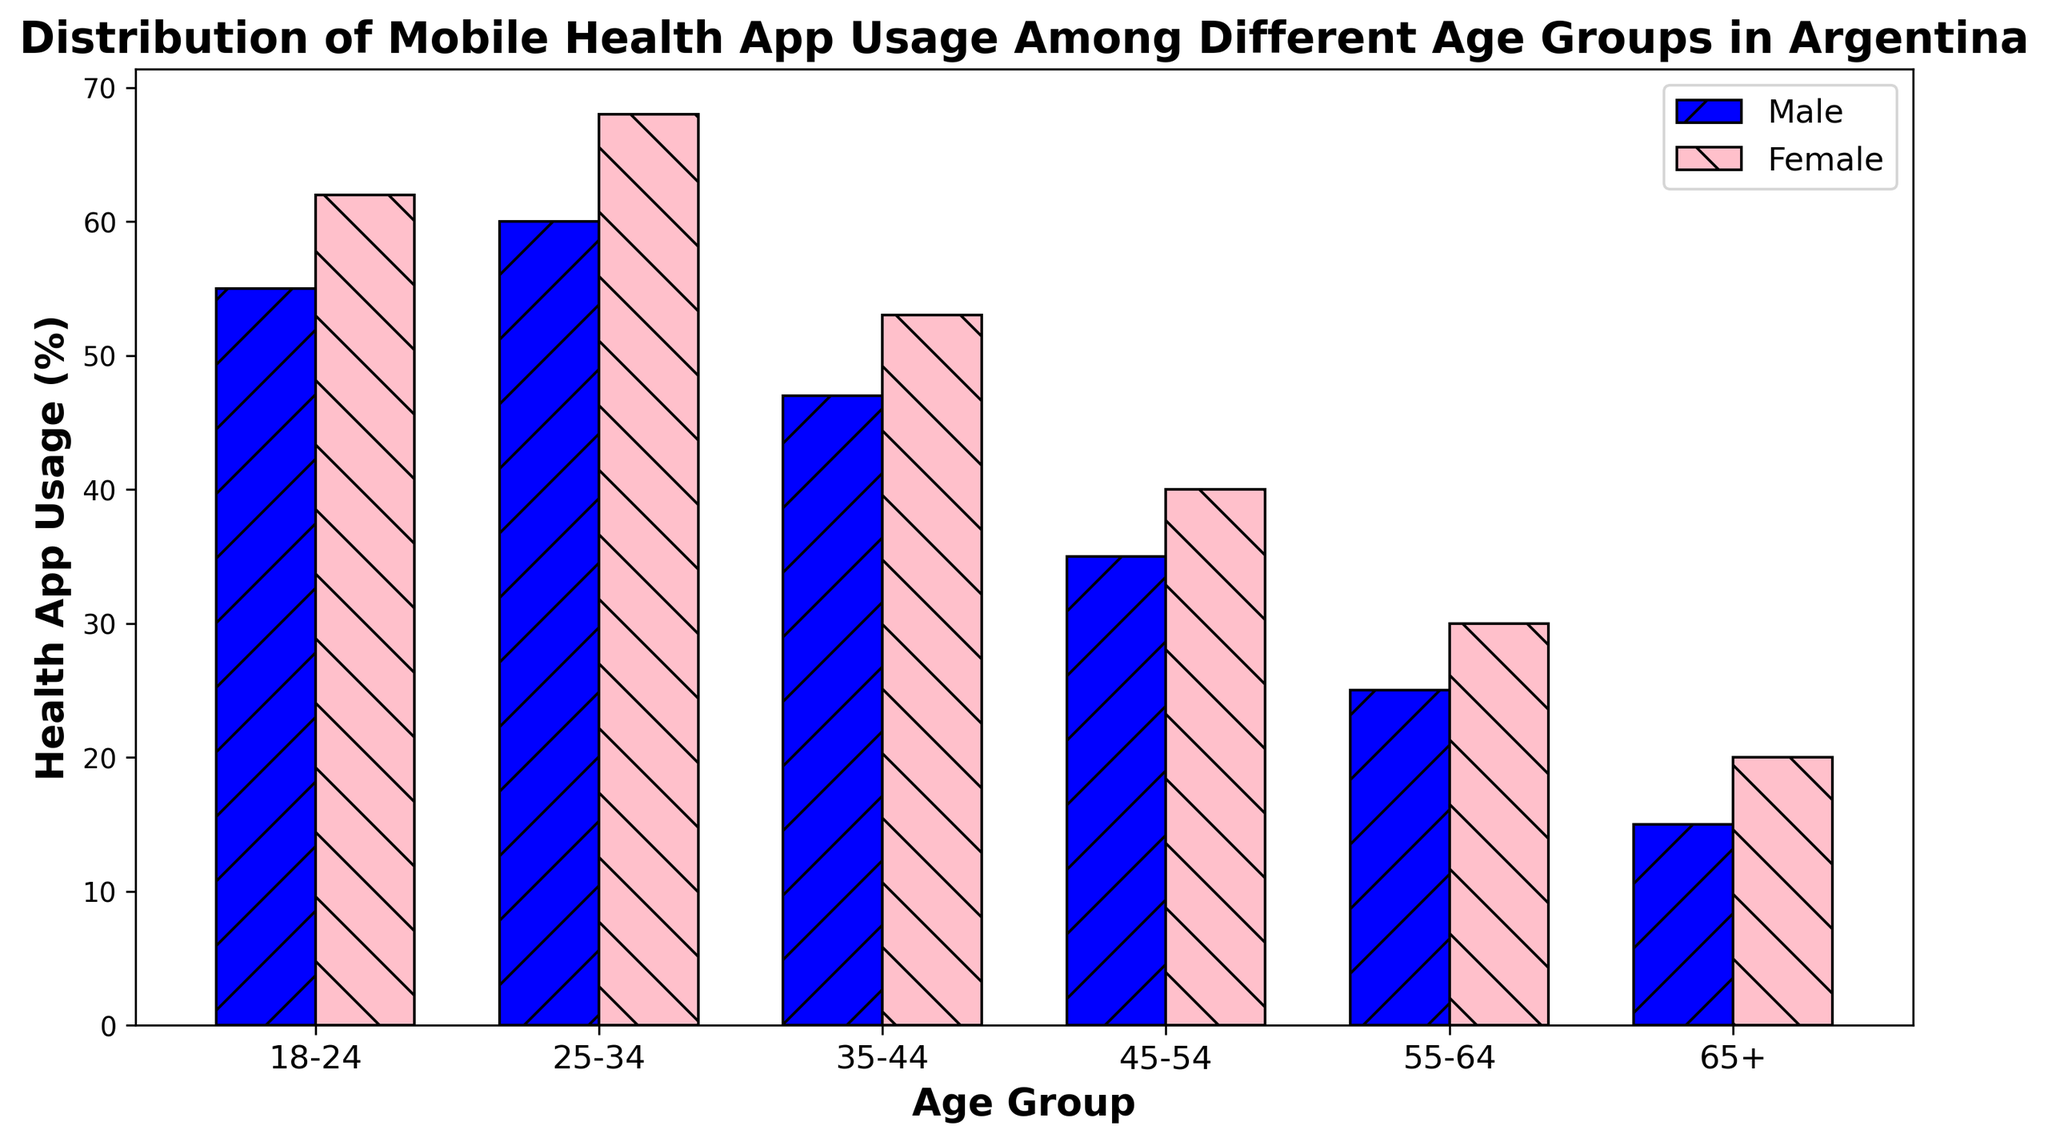Which age group has the highest percentage of mobile health app usage for males and how much is it? Look at the height of the blue bars representing males for all age groups. The highest bar is for the 25-34 age group with a value of 60%.
Answer: 25-34, 60% Which age group shows the largest difference in mobile health app usage between males and females? Calculate the difference between female and male usage percentages for each age group. The largest difference is observed in the 25-34 age group with a difference of 8% (68% - 60%).
Answer: 25-34, 8% What is the average mobile health app usage percentage across all age groups for females? Sum the percentage values for females across all age groups (62 + 68 + 53 + 40 + 30 + 20) and divide it by the number of age groups (6). This yields an average of 45.5%.
Answer: 45.5% Which age groups have a mobile health app usage difference between males and females greater than 5%? Calculate the differences for each age group and find those greater than 5%: 18-24 (7%), 25-34 (8%), 35-44 (6%), 45-54 (5%), 55-64 (5%), 65+ (5%).
Answer: 18-24, 25-34, 35-44 Is the mobile health app usage percentage for females in the 45-54 age group greater than that for males in the 35-44 age group? Compare the values directly from the plot: females 45-54 is 40% and males 35-44 is 47%. The female percentage is less than the male percentage.
Answer: No What is the visual difference in the height of bars between males and females in the 55-64 age group? Observe the relative length of the blue and pink bars for this age group. The female bar is visibly taller than the male bar whose difference is 5%.
Answer: Females How many age groups have a higher health app usage percentage for females compared to males? Compare each age group's bars for males and females: All age groups have higher female usage percentages. Thus, all six age groups fulfill this condition.
Answer: 6 In which age group is the usage percentage difference between males and females the smallest and what is the value? Calculate the difference for each age group and identify the smallest: the 45-54 age group with a difference of 5% (40% - 35% = 5%).
Answer: 45-54, 5% What is the combined health app usage percentage of males and females in the 18-24 age group? Sum the male and female percentages for 18-24 age group: 55% + 62% = 117%.
Answer: 117% What is the difference between the highest and lowest mobile health app usage percentages for females? Subtract the lowest female usage percentage (65+ age group, 20%) from the highest (25-34 age group, 68%): 68% - 20% = 48%.
Answer: 48% 